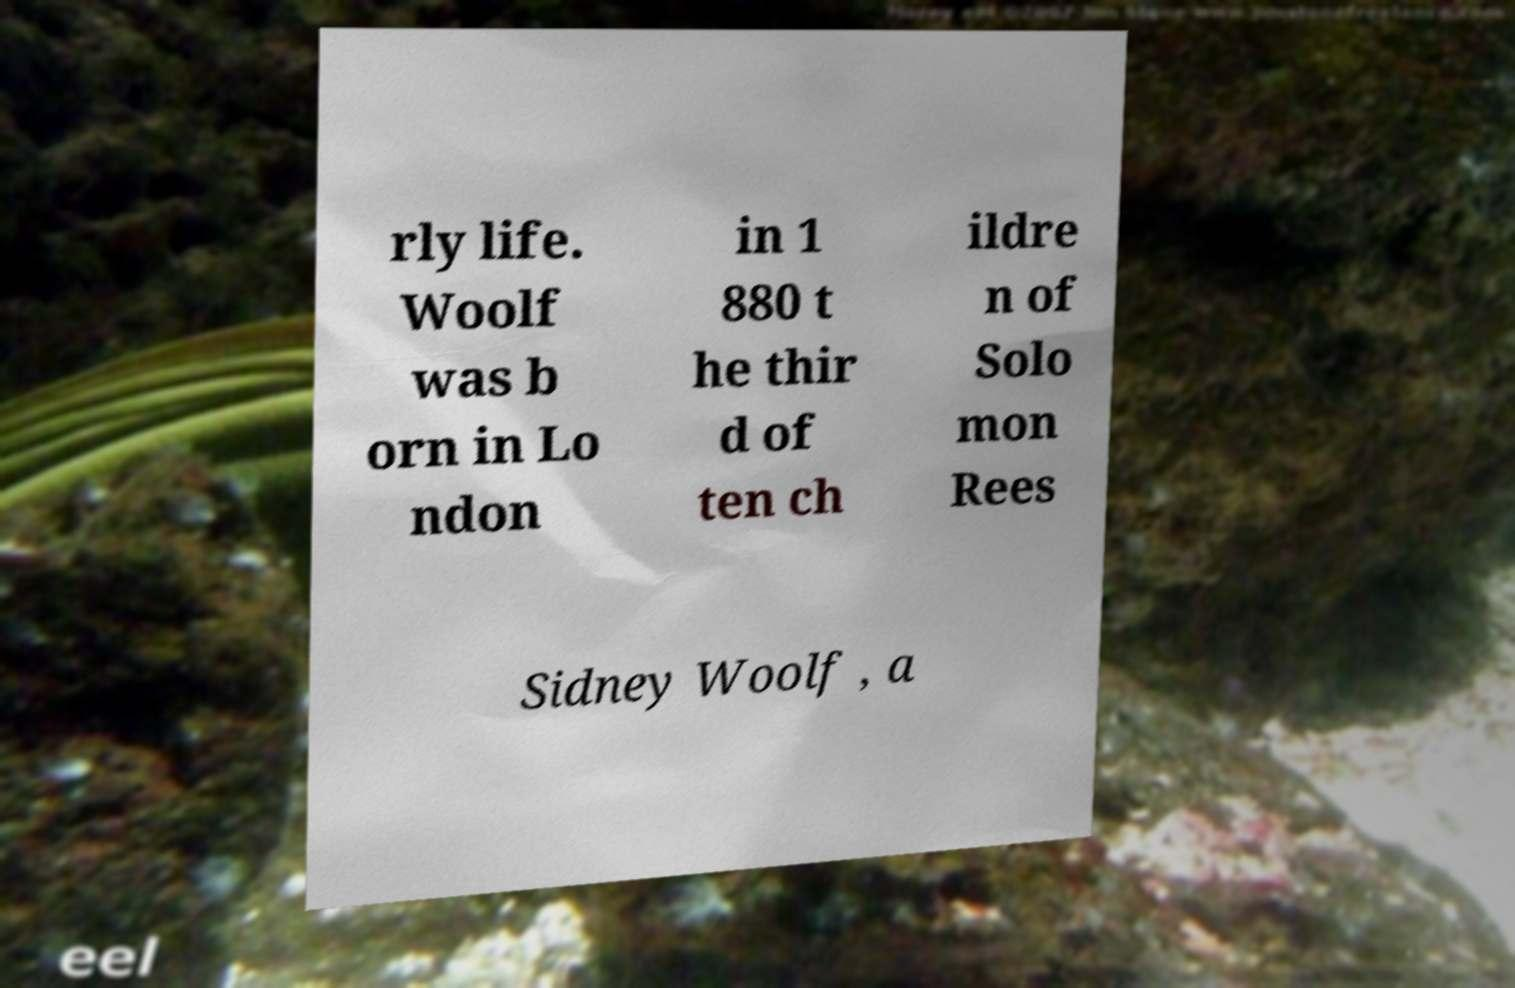Please read and relay the text visible in this image. What does it say? rly life. Woolf was b orn in Lo ndon in 1 880 t he thir d of ten ch ildre n of Solo mon Rees Sidney Woolf , a 